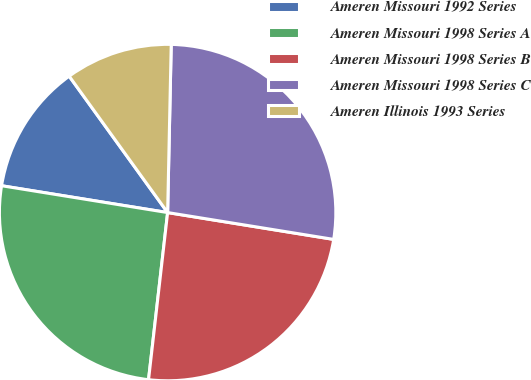Convert chart. <chart><loc_0><loc_0><loc_500><loc_500><pie_chart><fcel>Ameren Missouri 1992 Series<fcel>Ameren Missouri 1998 Series A<fcel>Ameren Missouri 1998 Series B<fcel>Ameren Missouri 1998 Series C<fcel>Ameren Illinois 1993 Series<nl><fcel>12.5%<fcel>25.74%<fcel>24.26%<fcel>27.21%<fcel>10.29%<nl></chart> 